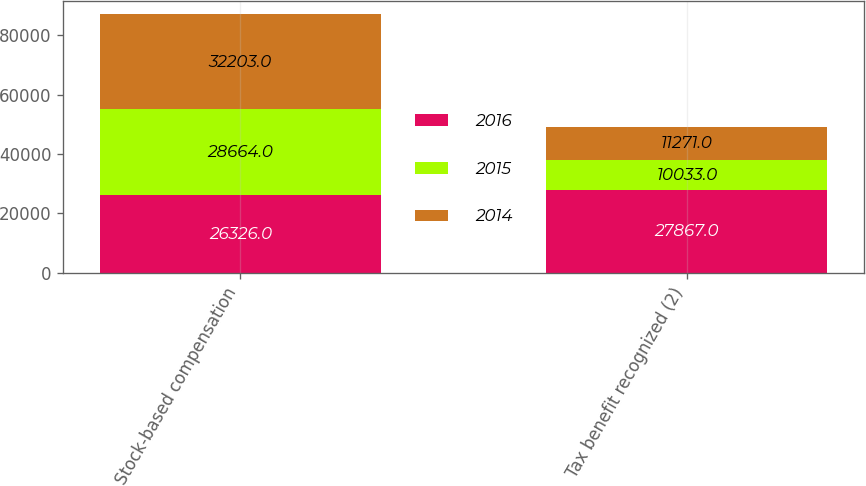Convert chart to OTSL. <chart><loc_0><loc_0><loc_500><loc_500><stacked_bar_chart><ecel><fcel>Stock-based compensation<fcel>Tax benefit recognized (2)<nl><fcel>2016<fcel>26326<fcel>27867<nl><fcel>2015<fcel>28664<fcel>10033<nl><fcel>2014<fcel>32203<fcel>11271<nl></chart> 